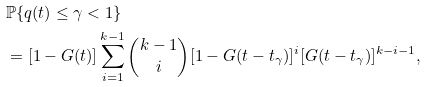Convert formula to latex. <formula><loc_0><loc_0><loc_500><loc_500>& \mathbb { P } \{ q ( t ) \leq \gamma < 1 \} \\ & = [ 1 - G ( t ) ] \sum _ { i = 1 } ^ { k - 1 } \binom { k - 1 } { i } [ 1 - G ( t - t _ { \gamma } ) ] ^ { i } [ G ( t - t _ { \gamma } ) ] ^ { k - i - 1 } ,</formula> 